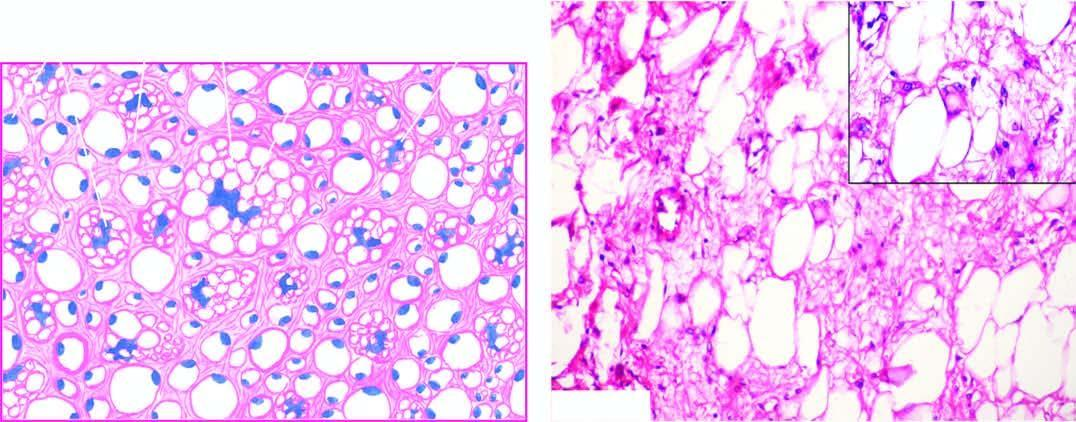what shows characteristic, univacuolated and multivacuolated lipoblasts with bizarre nuclei?
Answer the question using a single word or phrase. Tumour 